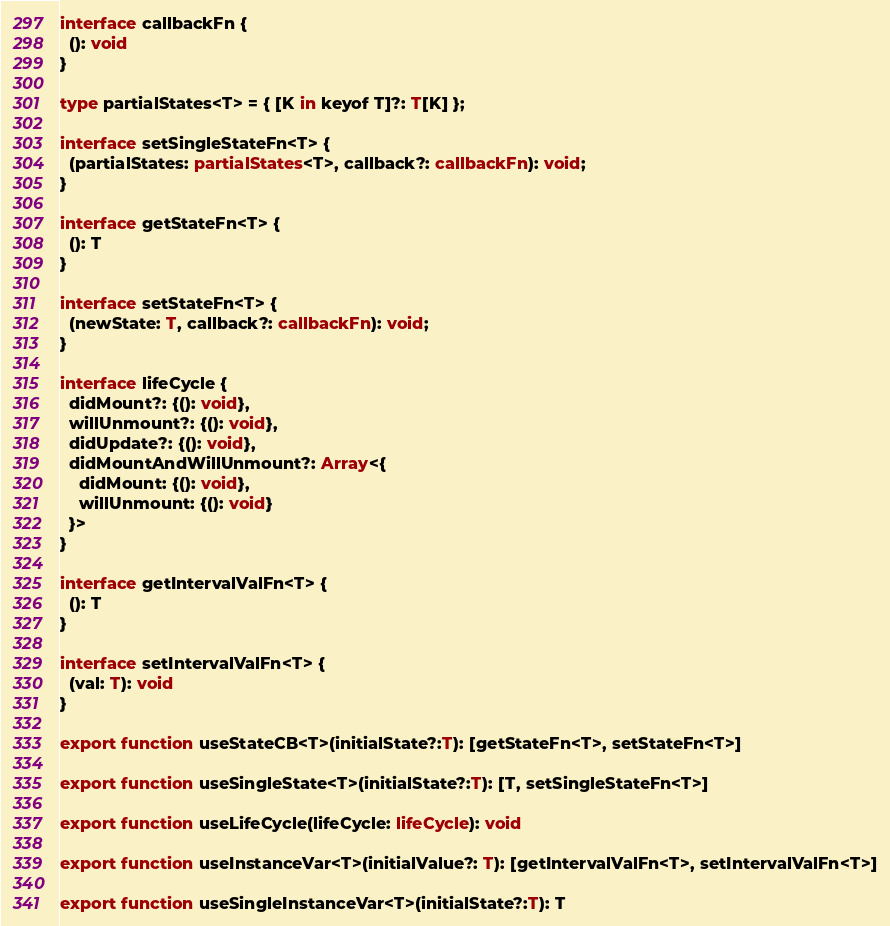Convert code to text. <code><loc_0><loc_0><loc_500><loc_500><_TypeScript_>interface callbackFn {
  (): void
}

type partialStates<T> = { [K in keyof T]?: T[K] };

interface setSingleStateFn<T> {
  (partialStates: partialStates<T>, callback?: callbackFn): void;
}

interface getStateFn<T> {
  (): T
}

interface setStateFn<T> {
  (newState: T, callback?: callbackFn): void;
}

interface lifeCycle {
  didMount?: {(): void},
  willUnmount?: {(): void},
  didUpdate?: {(): void},
  didMountAndWillUnmount?: Array<{
    didMount: {(): void},
    willUnmount: {(): void}
  }>
}

interface getIntervalValFn<T> {
  (): T
}

interface setIntervalValFn<T> {
  (val: T): void
}

export function useStateCB<T>(initialState?:T): [getStateFn<T>, setStateFn<T>]

export function useSingleState<T>(initialState?:T): [T, setSingleStateFn<T>]

export function useLifeCycle(lifeCycle: lifeCycle): void

export function useInstanceVar<T>(initialValue?: T): [getIntervalValFn<T>, setIntervalValFn<T>]

export function useSingleInstanceVar<T>(initialState?:T): T</code> 